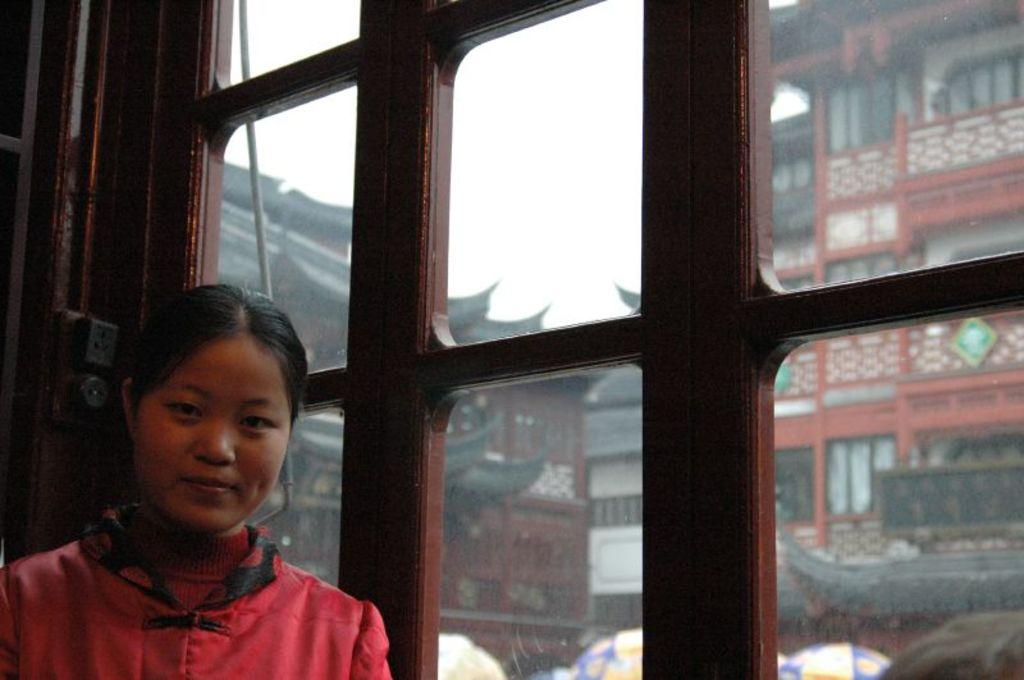Who is the main subject in the image? There is a woman in the image. Where is the woman located in relation to the window? The woman is standing near a window. What is the woman wearing? The woman is wearing a red dress. What can be seen outside the window? There are buildings visible outside the window. What is the condition of the sky in the image? The sky is clear in the image. How many babies are crawling on the woman's legs in the image? There are no babies or legs visible in the image; it only features a woman standing near a window. 